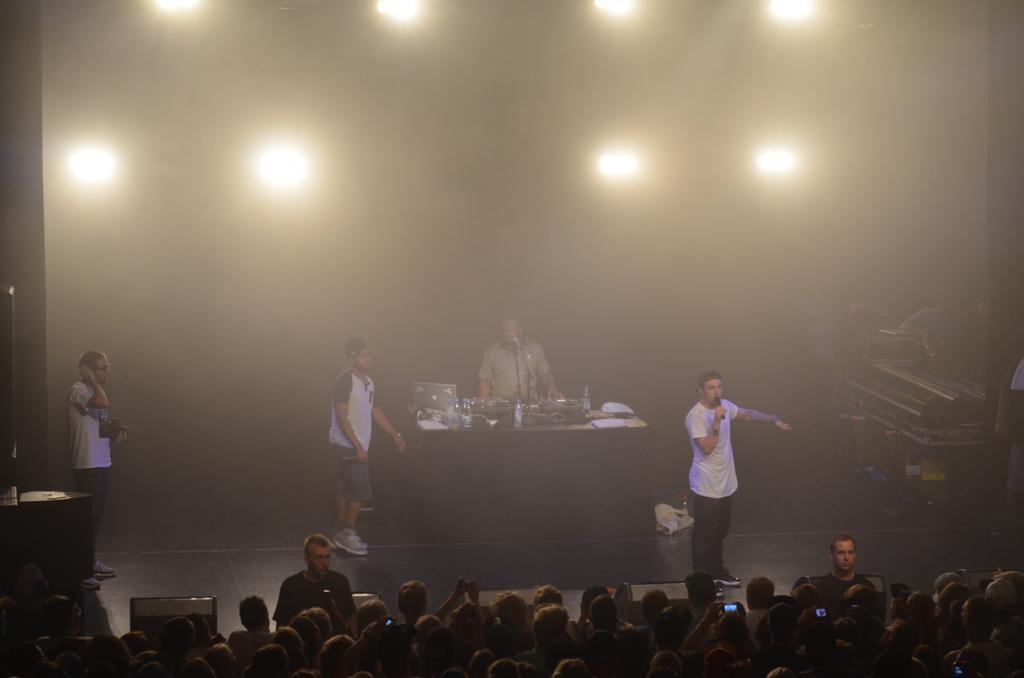Describe this image in one or two sentences. There is a crowd at the bottom of this image. We can see four people standing on the stage and we can see objects are present on the table. We can see lights at the top of this image. 